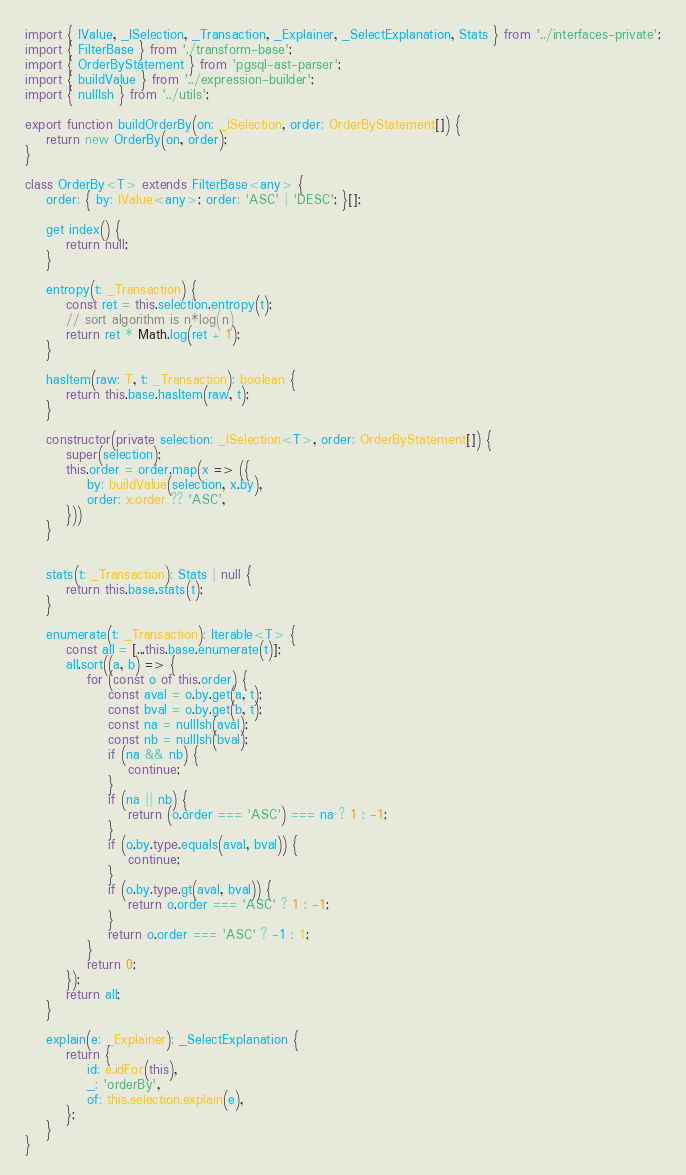Convert code to text. <code><loc_0><loc_0><loc_500><loc_500><_TypeScript_>import { IValue, _ISelection, _Transaction, _Explainer, _SelectExplanation, Stats } from '../interfaces-private';
import { FilterBase } from './transform-base';
import { OrderByStatement } from 'pgsql-ast-parser';
import { buildValue } from '../expression-builder';
import { nullIsh } from '../utils';

export function buildOrderBy(on: _ISelection, order: OrderByStatement[]) {
    return new OrderBy(on, order);
}

class OrderBy<T> extends FilterBase<any> {
    order: { by: IValue<any>; order: 'ASC' | 'DESC'; }[];

    get index() {
        return null;
    }

    entropy(t: _Transaction) {
        const ret = this.selection.entropy(t);
        // sort algorithm is n*log(n)
        return ret * Math.log(ret + 1);
    }

    hasItem(raw: T, t: _Transaction): boolean {
        return this.base.hasItem(raw, t);
    }

    constructor(private selection: _ISelection<T>, order: OrderByStatement[]) {
        super(selection);
        this.order = order.map(x => ({
            by: buildValue(selection, x.by),
            order: x.order ?? 'ASC',
        }))
    }


    stats(t: _Transaction): Stats | null {
        return this.base.stats(t);
    }

    enumerate(t: _Transaction): Iterable<T> {
        const all = [...this.base.enumerate(t)];
        all.sort((a, b) => {
            for (const o of this.order) {
                const aval = o.by.get(a, t);
                const bval = o.by.get(b, t);
                const na = nullIsh(aval);
                const nb = nullIsh(bval);
                if (na && nb) {
                    continue;
                }
                if (na || nb) {
                    return (o.order === 'ASC') === na ? 1 : -1;
                }
                if (o.by.type.equals(aval, bval)) {
                    continue;
                }
                if (o.by.type.gt(aval, bval)) {
                    return o.order === 'ASC' ? 1 : -1;
                }
                return o.order === 'ASC' ? -1 : 1;
            }
            return 0;
        });
        return all;
    }

    explain(e: _Explainer): _SelectExplanation {
        return {
            id: e.idFor(this),
            _: 'orderBy',
            of: this.selection.explain(e),
        };
    }
}</code> 